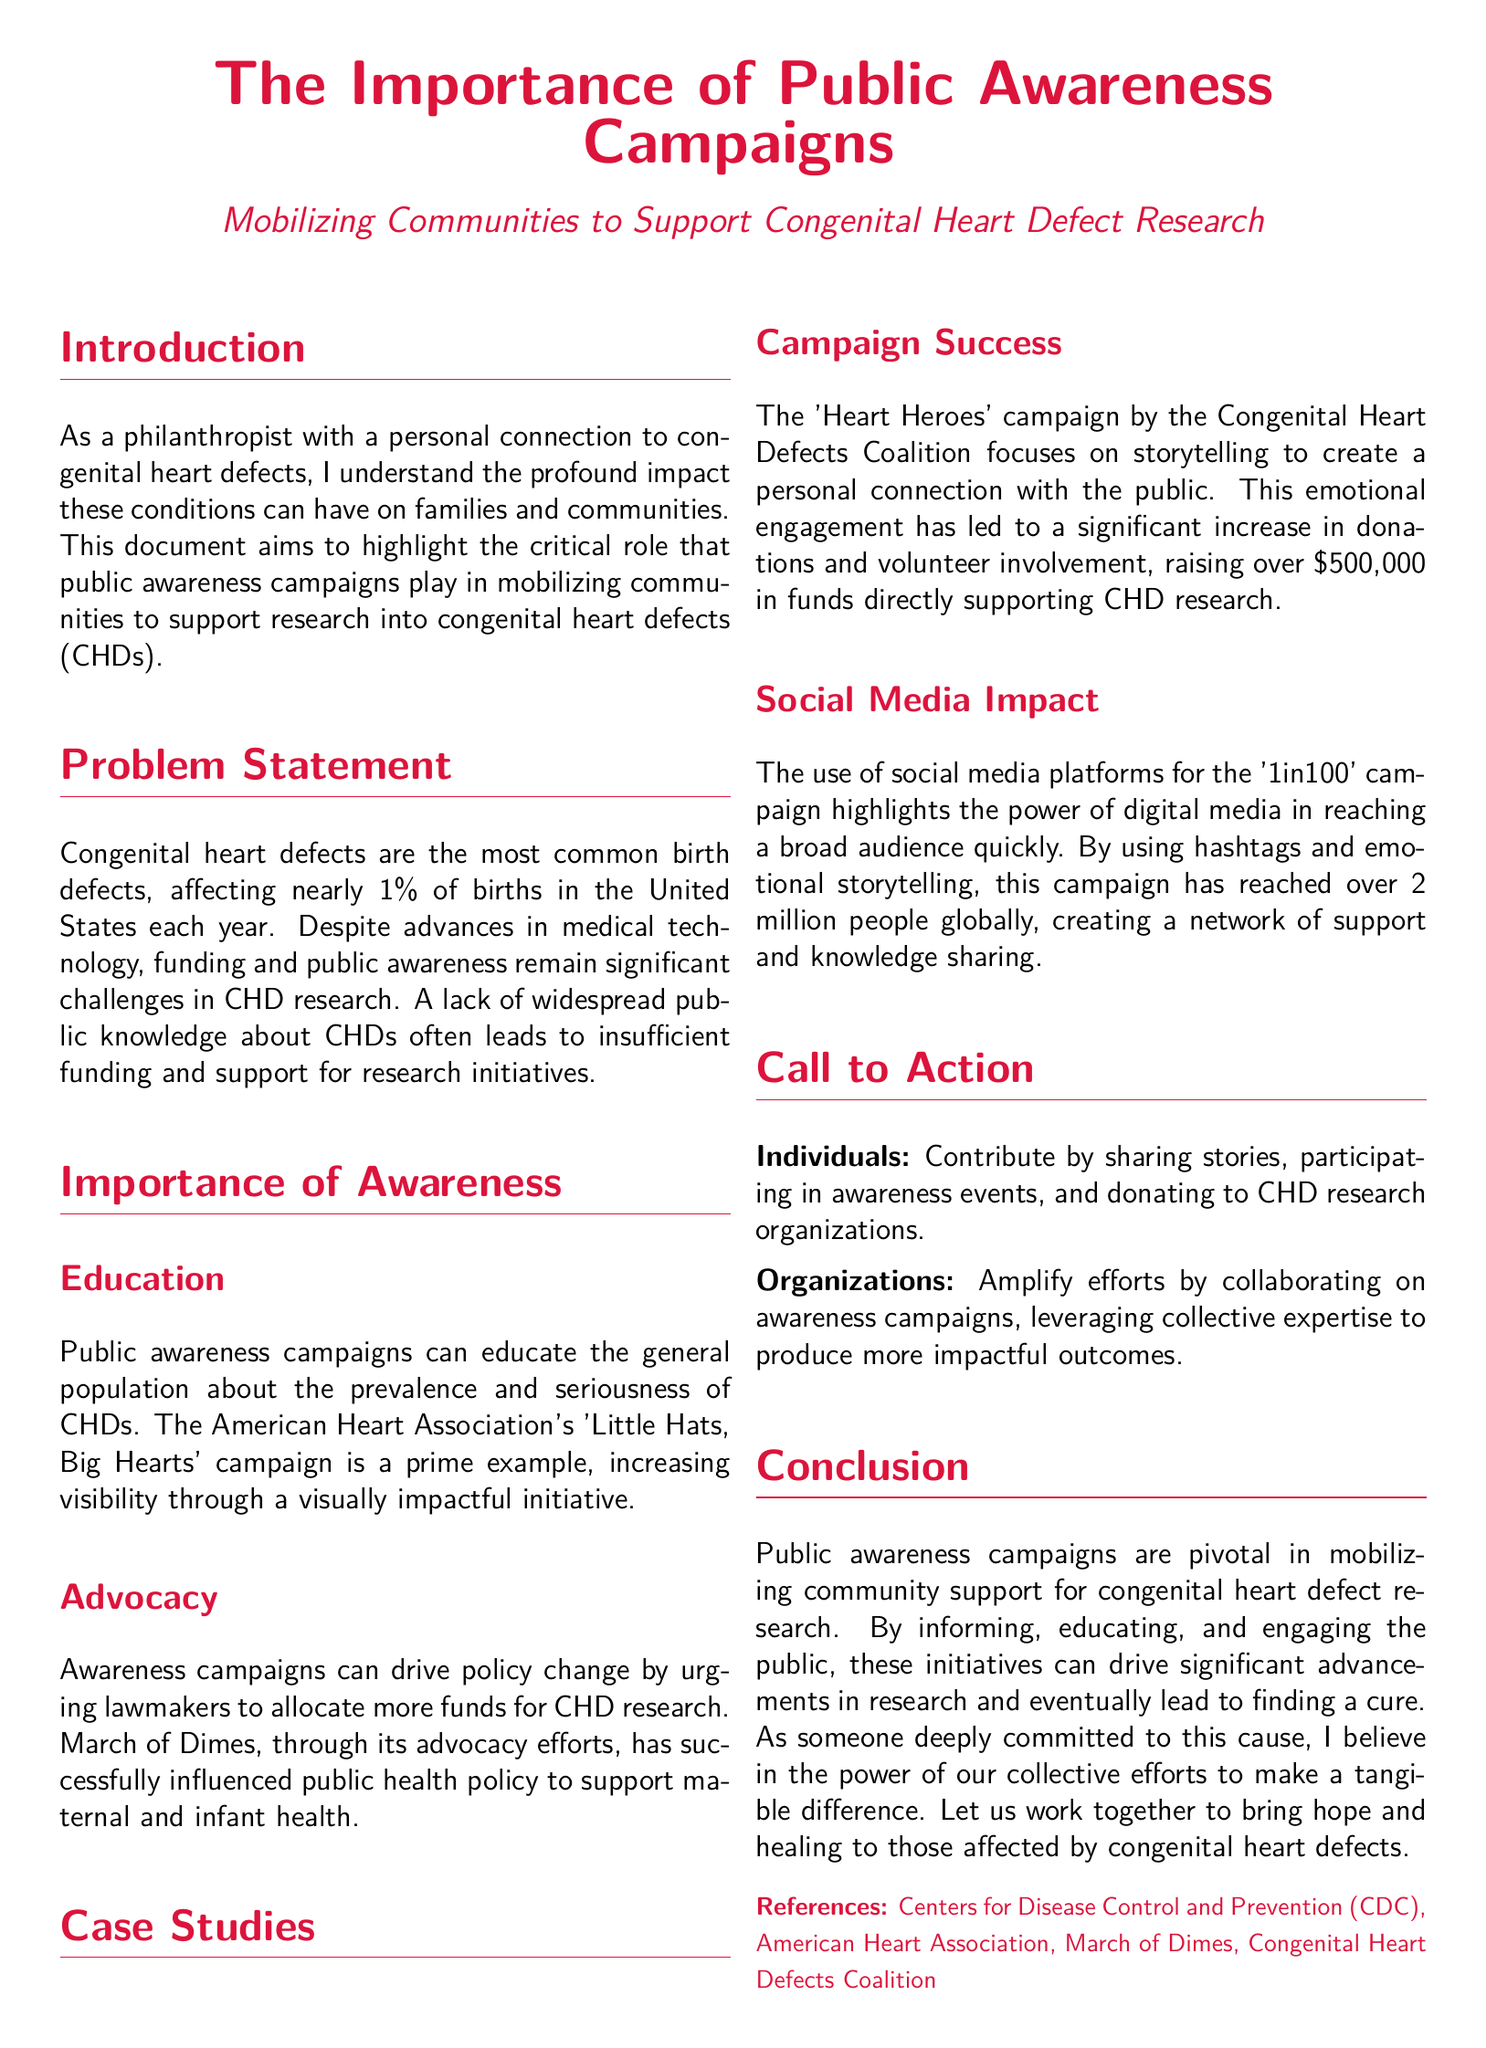What is the primary focus of the document? The document highlights the critical role of public awareness campaigns in mobilizing communities to support research into congenital heart defects.
Answer: Public awareness campaigns What percentage of births are affected by congenital heart defects in the U.S.? The document states that nearly 1% of births in the United States each year are affected by congenital heart defects.
Answer: 1% Which campaign is mentioned as an example of increasing visibility for congenital heart defects? The 'Little Hats, Big Hearts' campaign is given as a prime example of increasing visibility through impactful initiatives.
Answer: Little Hats, Big Hearts How much funding has the 'Heart Heroes' campaign raised for CHD research? The 'Heart Heroes' campaign has raised over $500,000 in funds supporting CHD research.
Answer: $500,000 What strategy did the '1in100' campaign use to reach a broad audience? The '1in100' campaign utilized hashtags and emotional storytelling to create awareness.
Answer: Hashtags and emotional storytelling What role can individuals play in supporting congenital heart defect research? Individuals can contribute by sharing stories, participating in awareness events, and donating to CHD research organizations.
Answer: Share stories, participate, donate What is the key outcome expected from public awareness campaigns according to the document? The expected outcome is to drive significant advancements in research and eventually lead to finding a cure for congenital heart defects.
Answer: Finding a cure Which organization influenced public health policy to support maternal and infant health? The document mentions March of Dimes as the organization that has successfully influenced public health policy.
Answer: March of Dimes What color is used prominently in the document title? The title of the document prominently features the color heart red.
Answer: Heart red 